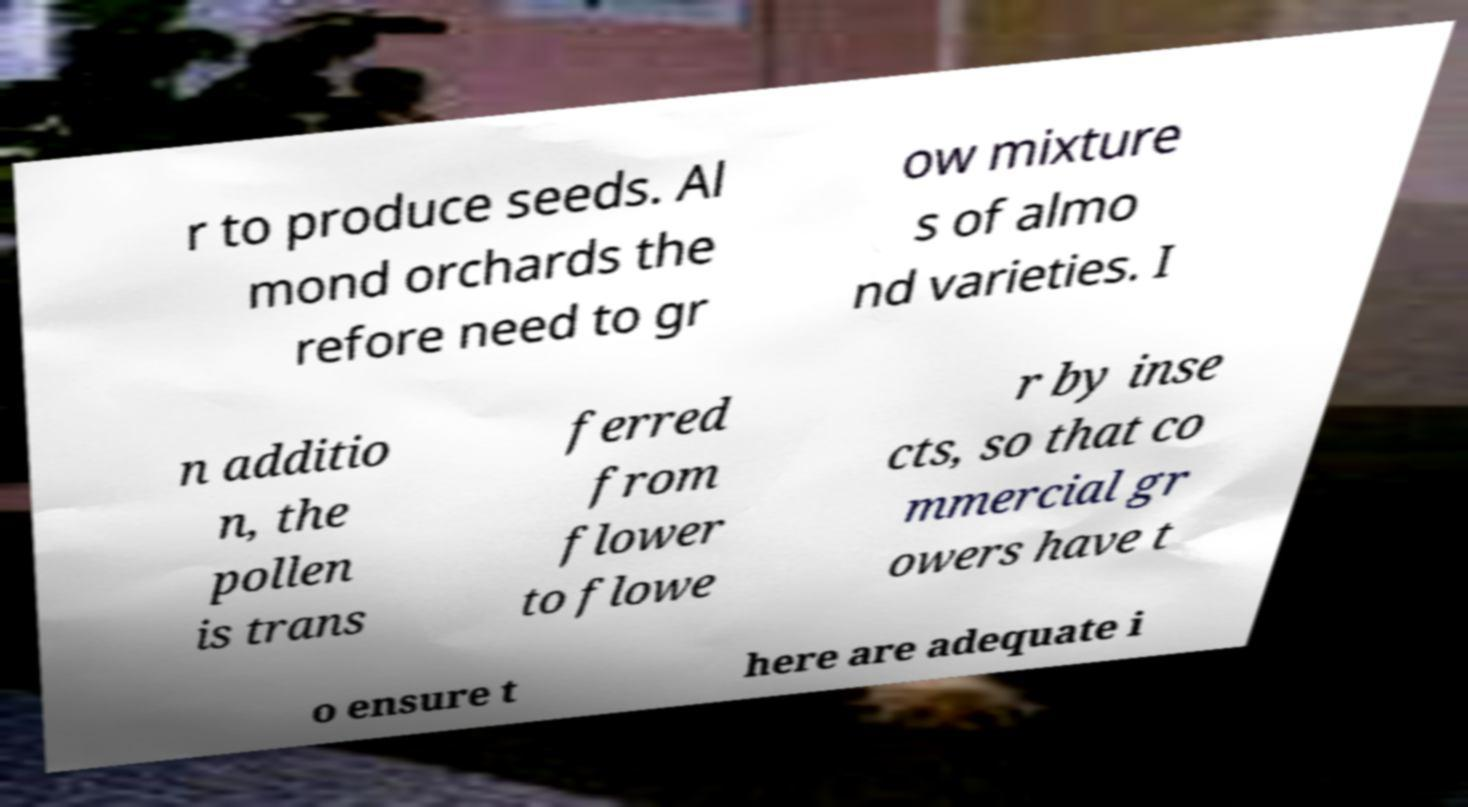Could you assist in decoding the text presented in this image and type it out clearly? r to produce seeds. Al mond orchards the refore need to gr ow mixture s of almo nd varieties. I n additio n, the pollen is trans ferred from flower to flowe r by inse cts, so that co mmercial gr owers have t o ensure t here are adequate i 